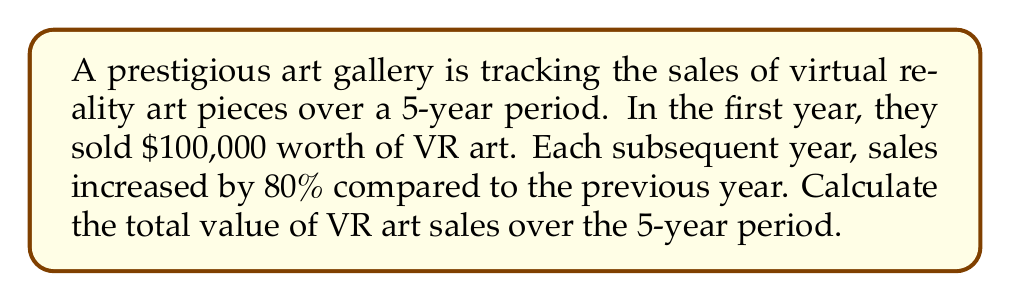Solve this math problem. Let's approach this step-by-step:

1) We're dealing with a geometric progression where:
   - Initial term, $a = 100,000$
   - Common ratio, $r = 1.80$ (80% increase = 1 + 0.80 = 1.80)
   - Number of terms, $n = 5$ (5 years)

2) The formula for the sum of a geometric series is:
   $$S_n = \frac{a(1-r^n)}{1-r}$$, where $r \neq 1$

3) Substituting our values:
   $$S_5 = \frac{100,000(1-1.80^5)}{1-1.80}$$

4) Calculate $1.80^5$:
   $1.80^5 = 18.89568$

5) Plug this back into our equation:
   $$S_5 = \frac{100,000(1-18.89568)}{1-1.80} = \frac{100,000(-17.89568)}{-0.80}$$

6) Simplify:
   $$S_5 = \frac{1,789,568}{0.80} = 2,236,960$$

Therefore, the total value of VR art sales over the 5-year period is $2,236,960.
Answer: $2,236,960 